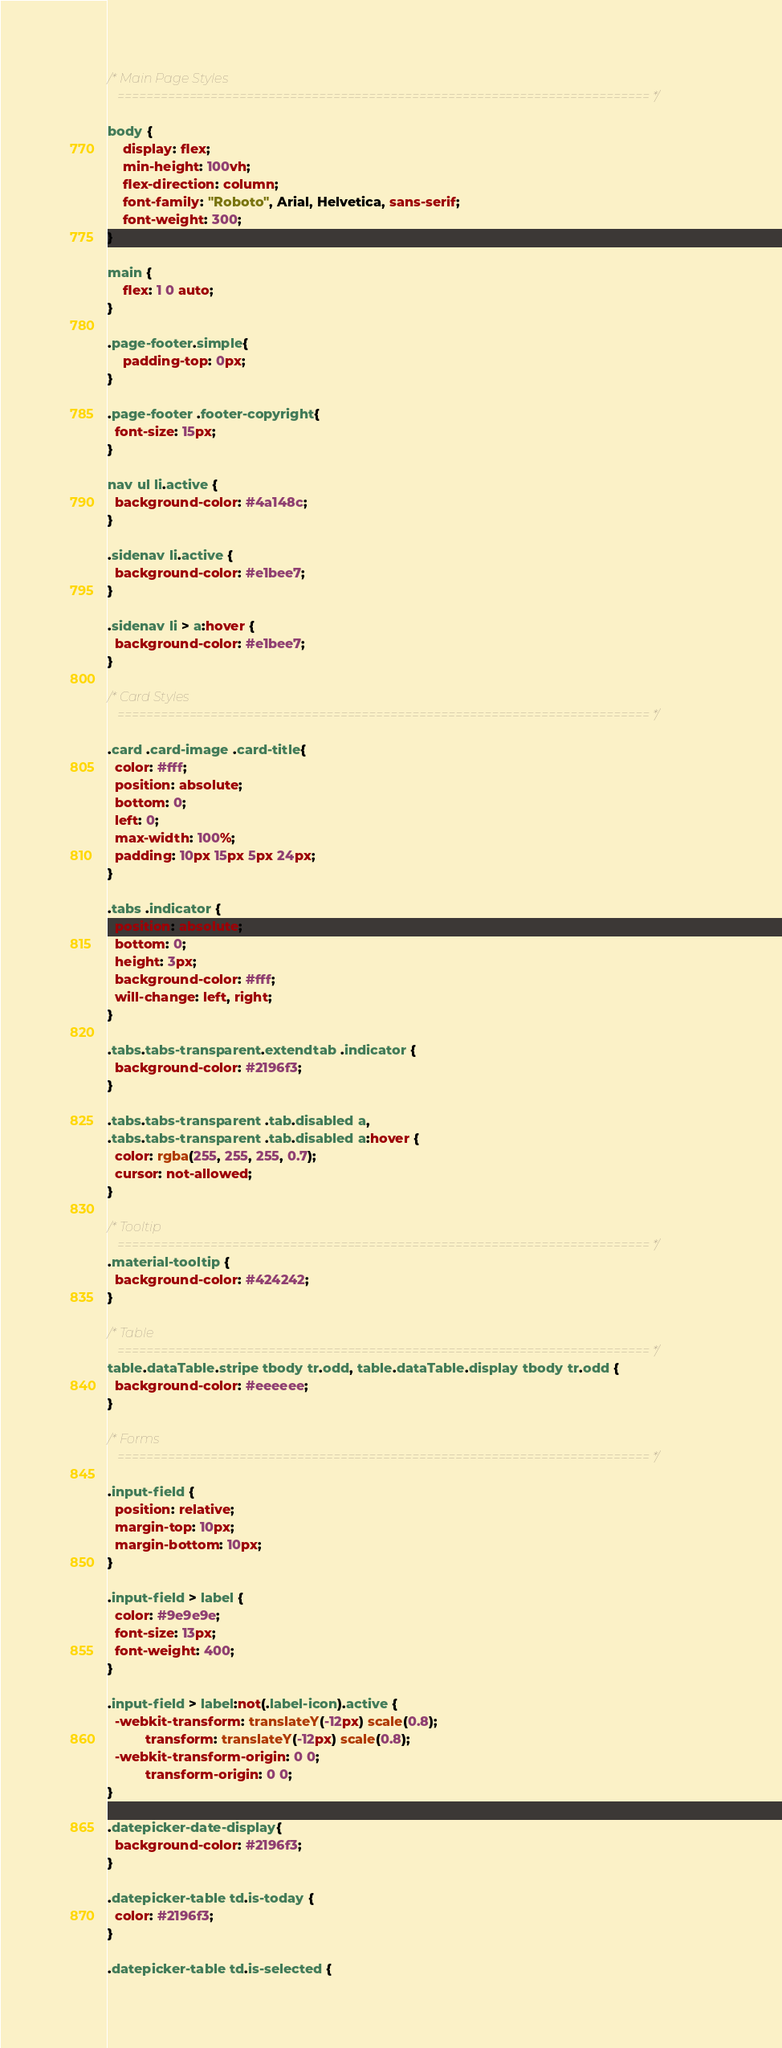Convert code to text. <code><loc_0><loc_0><loc_500><loc_500><_CSS_>/* Main Page Styles
   ========================================================================== */

body {
	display: flex;
    min-height: 100vh;
    flex-direction: column;
    font-family: "Roboto", Arial, Helvetica, sans-serif;
    font-weight: 300;
}

main {
    flex: 1 0 auto;
}

.page-footer.simple{
	padding-top: 0px;
}

.page-footer .footer-copyright{
  font-size: 15px;
}

nav ul li.active {
  background-color: #4a148c;
}

.sidenav li.active {
  background-color: #e1bee7;
}

.sidenav li > a:hover {
  background-color: #e1bee7;
}

/* Card Styles
   ========================================================================== */

.card .card-image .card-title{
  color: #fff;
  position: absolute;
  bottom: 0;
  left: 0;
  max-width: 100%;
  padding: 10px 15px 5px 24px;
}

.tabs .indicator {
  position: absolute;
  bottom: 0;
  height: 3px;
  background-color: #fff;
  will-change: left, right;
}

.tabs.tabs-transparent.extendtab .indicator {
  background-color: #2196f3;
}

.tabs.tabs-transparent .tab.disabled a,
.tabs.tabs-transparent .tab.disabled a:hover {
  color: rgba(255, 255, 255, 0.7);
  cursor: not-allowed;
}

/* Tooltip
   ========================================================================== */
.material-tooltip {
  background-color: #424242;
}

/* Table
   ========================================================================== */
table.dataTable.stripe tbody tr.odd, table.dataTable.display tbody tr.odd {
  background-color: #eeeeee;
}

/* Forms
   ========================================================================== */

.input-field {
  position: relative;
  margin-top: 10px;
  margin-bottom: 10px;
}

.input-field > label {
  color: #9e9e9e;
  font-size: 13px;
  font-weight: 400;
}

.input-field > label:not(.label-icon).active {
  -webkit-transform: translateY(-12px) scale(0.8);
          transform: translateY(-12px) scale(0.8);
  -webkit-transform-origin: 0 0;
          transform-origin: 0 0;
}

.datepicker-date-display{
  background-color: #2196f3; 
}

.datepicker-table td.is-today {
  color: #2196f3;
}

.datepicker-table td.is-selected {</code> 